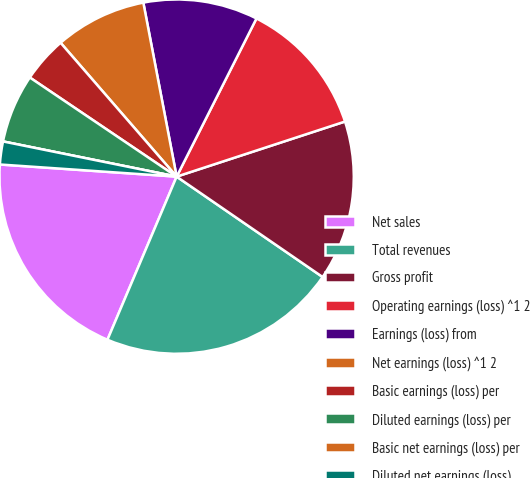Convert chart to OTSL. <chart><loc_0><loc_0><loc_500><loc_500><pie_chart><fcel>Net sales<fcel>Total revenues<fcel>Gross profit<fcel>Operating earnings (loss) ^1 2<fcel>Earnings (loss) from<fcel>Net earnings (loss) ^1 2<fcel>Basic earnings (loss) per<fcel>Diluted earnings (loss) per<fcel>Basic net earnings (loss) per<fcel>Diluted net earnings (loss)<nl><fcel>19.71%<fcel>21.8%<fcel>14.62%<fcel>12.53%<fcel>10.45%<fcel>8.36%<fcel>4.18%<fcel>6.27%<fcel>0.0%<fcel>2.09%<nl></chart> 